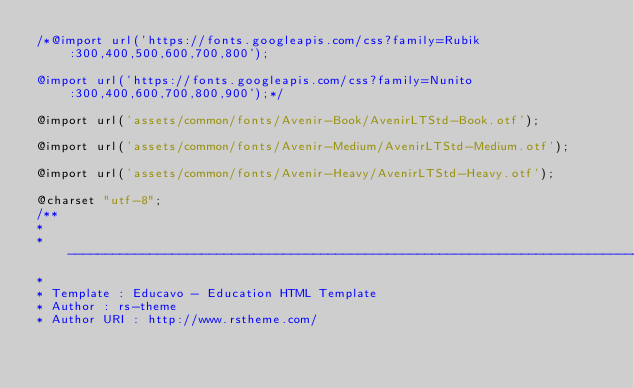Convert code to text. <code><loc_0><loc_0><loc_500><loc_500><_CSS_>/*@import url('https://fonts.googleapis.com/css?family=Rubik:300,400,500,600,700,800');

@import url('https://fonts.googleapis.com/css?family=Nunito:300,400,600,700,800,900');*/

@import url('assets/common/fonts/Avenir-Book/AvenirLTStd-Book.otf');

@import url('assets/common/fonts/Avenir-Medium/AvenirLTStd-Medium.otf');

@import url('assets/common/fonts/Avenir-Heavy/AvenirLTStd-Heavy.otf');

@charset "utf-8";
/** 
* 
* -----------------------------------------------------------------------------
*
* Template : Educavo - Education HTML Template
* Author : rs-theme
* Author URI : http://www.rstheme.com/ </code> 